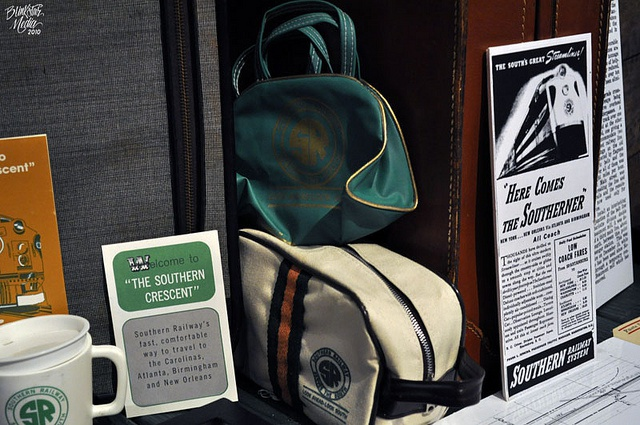Describe the objects in this image and their specific colors. I can see suitcase in black and gray tones, handbag in black, gray, and beige tones, handbag in black, teal, and darkblue tones, and cup in black, darkgray, and lightgray tones in this image. 